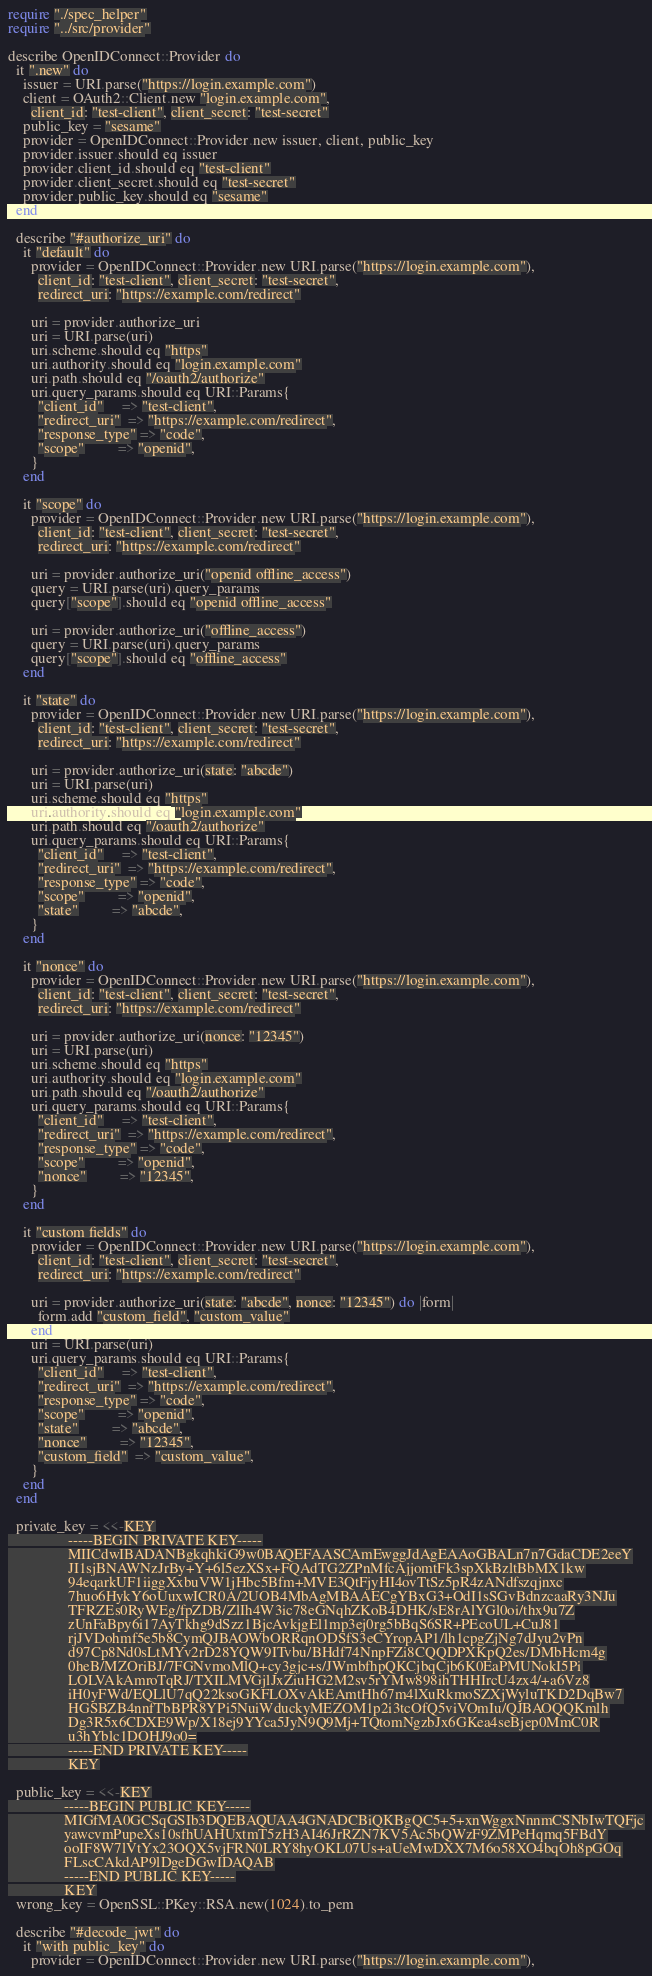<code> <loc_0><loc_0><loc_500><loc_500><_Crystal_>require "./spec_helper"
require "../src/provider"

describe OpenIDConnect::Provider do
  it ".new" do
    issuer = URI.parse("https://login.example.com")
    client = OAuth2::Client.new "login.example.com",
      client_id: "test-client", client_secret: "test-secret"
    public_key = "sesame"
    provider = OpenIDConnect::Provider.new issuer, client, public_key
    provider.issuer.should eq issuer
    provider.client_id.should eq "test-client"
    provider.client_secret.should eq "test-secret"
    provider.public_key.should eq "sesame"
  end

  describe "#authorize_uri" do
    it "default" do
      provider = OpenIDConnect::Provider.new URI.parse("https://login.example.com"),
        client_id: "test-client", client_secret: "test-secret",
        redirect_uri: "https://example.com/redirect"

      uri = provider.authorize_uri
      uri = URI.parse(uri)
      uri.scheme.should eq "https"
      uri.authority.should eq "login.example.com"
      uri.path.should eq "/oauth2/authorize"
      uri.query_params.should eq URI::Params{
        "client_id"     => "test-client",
        "redirect_uri"  => "https://example.com/redirect",
        "response_type" => "code",
        "scope"         => "openid",
      }
    end

    it "scope" do
      provider = OpenIDConnect::Provider.new URI.parse("https://login.example.com"),
        client_id: "test-client", client_secret: "test-secret",
        redirect_uri: "https://example.com/redirect"

      uri = provider.authorize_uri("openid offline_access")
      query = URI.parse(uri).query_params
      query["scope"].should eq "openid offline_access"

      uri = provider.authorize_uri("offline_access")
      query = URI.parse(uri).query_params
      query["scope"].should eq "offline_access"
    end

    it "state" do
      provider = OpenIDConnect::Provider.new URI.parse("https://login.example.com"),
        client_id: "test-client", client_secret: "test-secret",
        redirect_uri: "https://example.com/redirect"

      uri = provider.authorize_uri(state: "abcde")
      uri = URI.parse(uri)
      uri.scheme.should eq "https"
      uri.authority.should eq "login.example.com"
      uri.path.should eq "/oauth2/authorize"
      uri.query_params.should eq URI::Params{
        "client_id"     => "test-client",
        "redirect_uri"  => "https://example.com/redirect",
        "response_type" => "code",
        "scope"         => "openid",
        "state"         => "abcde",
      }
    end

    it "nonce" do
      provider = OpenIDConnect::Provider.new URI.parse("https://login.example.com"),
        client_id: "test-client", client_secret: "test-secret",
        redirect_uri: "https://example.com/redirect"

      uri = provider.authorize_uri(nonce: "12345")
      uri = URI.parse(uri)
      uri.scheme.should eq "https"
      uri.authority.should eq "login.example.com"
      uri.path.should eq "/oauth2/authorize"
      uri.query_params.should eq URI::Params{
        "client_id"     => "test-client",
        "redirect_uri"  => "https://example.com/redirect",
        "response_type" => "code",
        "scope"         => "openid",
        "nonce"         => "12345",
      }
    end

    it "custom fields" do
      provider = OpenIDConnect::Provider.new URI.parse("https://login.example.com"),
        client_id: "test-client", client_secret: "test-secret",
        redirect_uri: "https://example.com/redirect"

      uri = provider.authorize_uri(state: "abcde", nonce: "12345") do |form|
        form.add "custom_field", "custom_value"
      end
      uri = URI.parse(uri)
      uri.query_params.should eq URI::Params{
        "client_id"     => "test-client",
        "redirect_uri"  => "https://example.com/redirect",
        "response_type" => "code",
        "scope"         => "openid",
        "state"         => "abcde",
        "nonce"         => "12345",
        "custom_field"  => "custom_value",
      }
    end
  end

  private_key = <<-KEY
                -----BEGIN PRIVATE KEY-----
                MIICdwIBADANBgkqhkiG9w0BAQEFAASCAmEwggJdAgEAAoGBALn7n7GdaCDE2eeY
                JI1sjBNAWNzJrBy+Y+6l5ezXSx+FQAdTG2ZPnMfcAjjomtFk3spXkBzltBbMX1kw
                94eqarkUF1iiggXxbuVW1jHbc5Bfm+MVE3QtFjyHI4ovTtSz5pR4zANdfszqjnxc
                7huo6HykY6oUuxwICR0A/2UOB4MbAgMBAAECgYBxG3+OdI1sSGvBdnzcaaRy3NJu
                TFRZEs0RyWEg/fpZDB/ZlIh4W3ic78eGNqhZKoB4DHK/sE8rAlYGl0oi/thx9u7Z
                zUnFaBpy6i17AyTkhg9dSzz1BjcAvkjgEl1mp3ej0rg5bBqS6SR+PEcoUL+CuJ81
                rjJVDohmf5e5b8CymQJBAOWbORRqnODSfS3eCYropAP1/lh1cpgZjNg7dJyu2vPn
                d97Cp8Nd0sLtMYv2rD28YQW9ITvbu/BHdf74NnpFZi8CQQDPXKpQ2es/DMbHcm4g
                0heB/MZOriBJ/7FGNvmoMlQ+cy3gjc+s/JWmbfhpQKCjbqCjb6K0EaPMUNokI5Pi
                LOLVAkAmroTqRJ/TXILMVGjlJxZiuHG2M2sv5rYMw898ihTHHIrcU4zx4/+a6Vz8
                iH0yFWd/EQLlU7qQ22ksoGKFLOXvAkEAmtHh67m4lXuRkmoSZXjWyluTKD2DqBw7
                HGSBZB4nnfTbBPR8YPi5NuiWduckyMEZOM1p2i3tcOfQ5viVOmIu/QJBAOQQKmlh
                Dg3R5x6CDXE9Wp/X18ej9YYca5JyN9Q9Mj+TQtomNgzbJx6GKea4seBjep0MmC0R
                u3hYblc1DOHJ9o0=
                -----END PRIVATE KEY-----
                KEY

  public_key = <<-KEY
               -----BEGIN PUBLIC KEY-----
               MIGfMA0GCSqGSIb3DQEBAQUAA4GNADCBiQKBgQC5+5+xnWggxNnnmCSNbIwTQFjc
               yawcvmPupeXs10sfhUAHUxtmT5zH3AI46JrRZN7KV5Ac5bQWzF9ZMPeHqmq5FBdY
               ooIF8W7lVtYx23OQX5vjFRN0LRY8hyOKL07Us+aUeMwDXX7M6o58XO4bqOh8pGOq
               FLscCAkdAP9lDgeDGwIDAQAB
               -----END PUBLIC KEY-----
               KEY
  wrong_key = OpenSSL::PKey::RSA.new(1024).to_pem

  describe "#decode_jwt" do
    it "with public_key" do
      provider = OpenIDConnect::Provider.new URI.parse("https://login.example.com"),</code> 